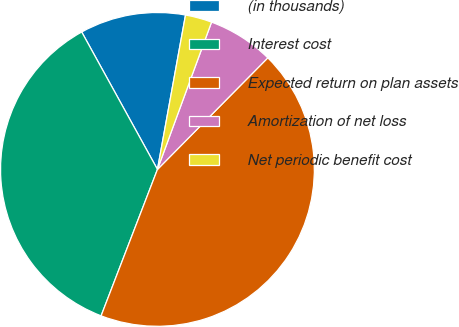Convert chart. <chart><loc_0><loc_0><loc_500><loc_500><pie_chart><fcel>(in thousands)<fcel>Interest cost<fcel>Expected return on plan assets<fcel>Amortization of net loss<fcel>Net periodic benefit cost<nl><fcel>10.88%<fcel>36.13%<fcel>43.43%<fcel>6.81%<fcel>2.74%<nl></chart> 